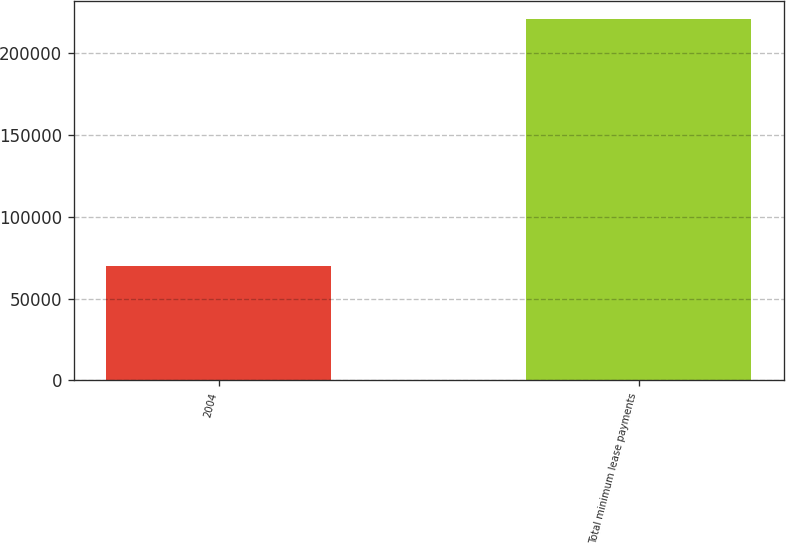Convert chart to OTSL. <chart><loc_0><loc_0><loc_500><loc_500><bar_chart><fcel>2004<fcel>Total minimum lease payments<nl><fcel>70250<fcel>220974<nl></chart> 